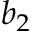<formula> <loc_0><loc_0><loc_500><loc_500>b _ { 2 }</formula> 